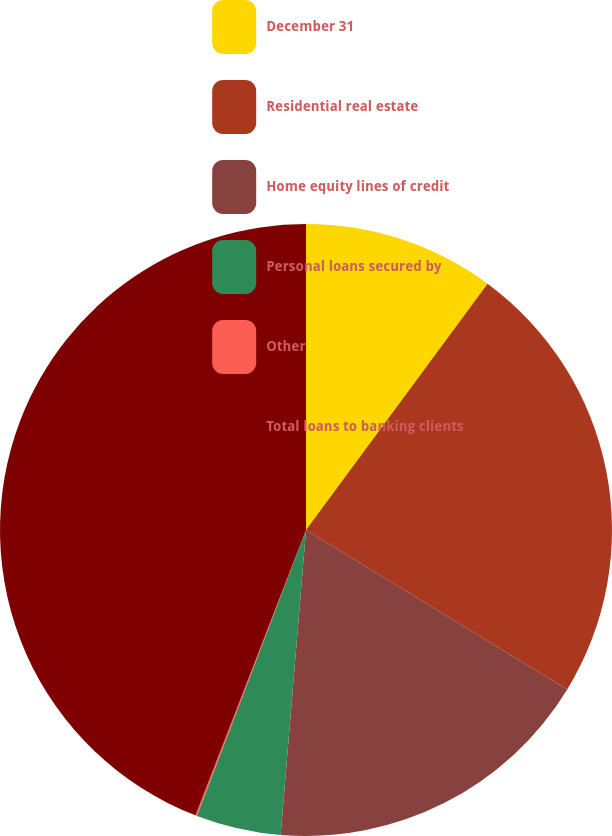Convert chart to OTSL. <chart><loc_0><loc_0><loc_500><loc_500><pie_chart><fcel>December 31<fcel>Residential real estate<fcel>Home equity lines of credit<fcel>Personal loans secured by<fcel>Other<fcel>Total loans to banking clients<nl><fcel>10.11%<fcel>23.61%<fcel>17.6%<fcel>4.48%<fcel>0.08%<fcel>44.12%<nl></chart> 